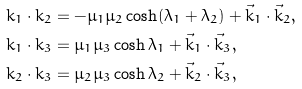Convert formula to latex. <formula><loc_0><loc_0><loc_500><loc_500>k _ { 1 } \cdot k _ { 2 } & = - \mu _ { 1 } \mu _ { 2 } \cosh ( \lambda _ { 1 } + \lambda _ { 2 } ) + \vec { k } _ { 1 } \cdot \vec { k } _ { 2 } , \\ k _ { 1 } \cdot k _ { 3 } & = \mu _ { 1 } \mu _ { 3 } \cosh \lambda _ { 1 } + \vec { k } _ { 1 } \cdot \vec { k } _ { 3 } , \\ k _ { 2 } \cdot k _ { 3 } & = \mu _ { 2 } \mu _ { 3 } \cosh \lambda _ { 2 } + \vec { k } _ { 2 } \cdot \vec { k } _ { 3 } ,</formula> 